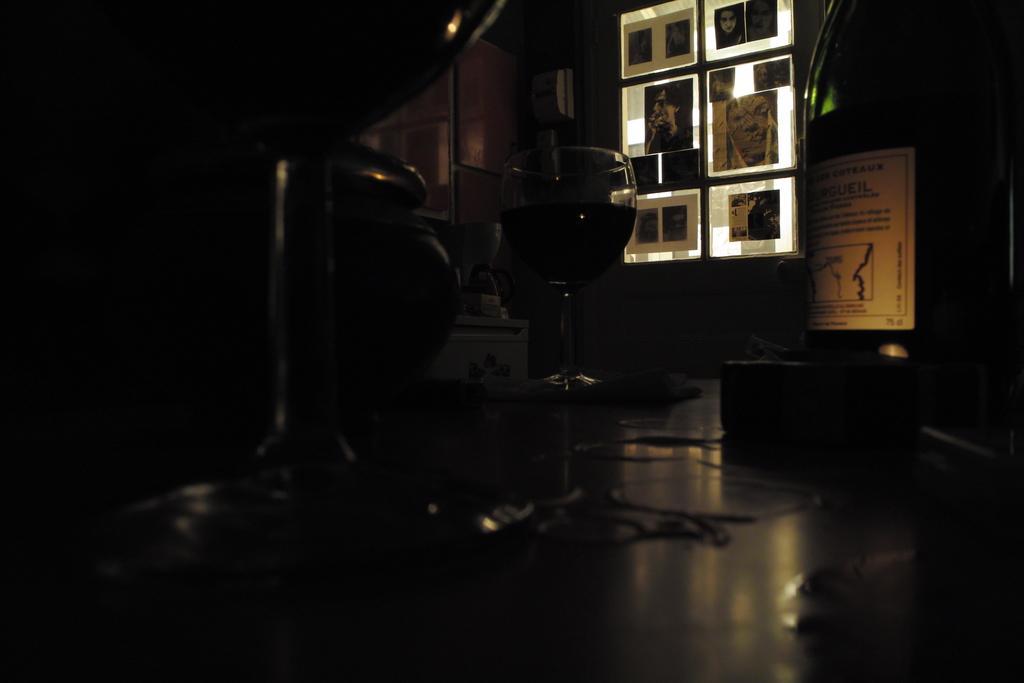Please provide a concise description of this image. In this picture I can see a glass in front and I can see the posters. On the right side of this picture I can see something is written on the paper and I see that this picture is in dark. 